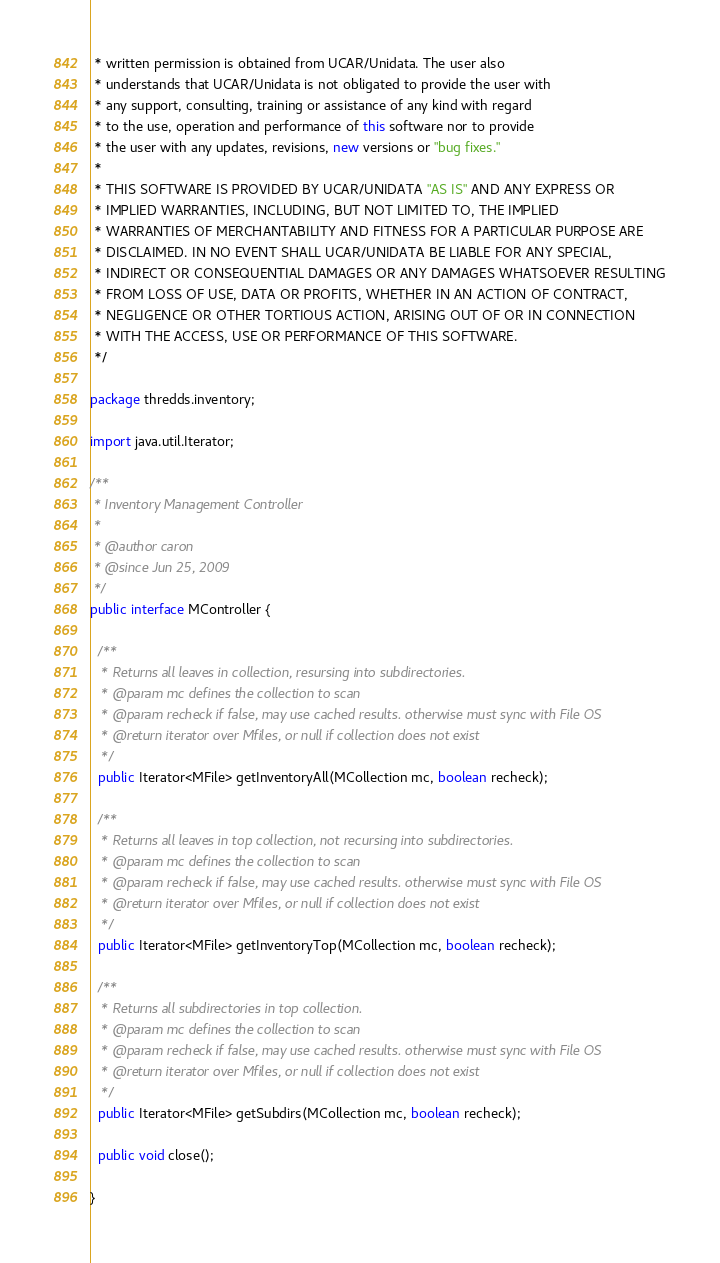Convert code to text. <code><loc_0><loc_0><loc_500><loc_500><_Java_> * written permission is obtained from UCAR/Unidata. The user also
 * understands that UCAR/Unidata is not obligated to provide the user with
 * any support, consulting, training or assistance of any kind with regard
 * to the use, operation and performance of this software nor to provide
 * the user with any updates, revisions, new versions or "bug fixes."
 *
 * THIS SOFTWARE IS PROVIDED BY UCAR/UNIDATA "AS IS" AND ANY EXPRESS OR
 * IMPLIED WARRANTIES, INCLUDING, BUT NOT LIMITED TO, THE IMPLIED
 * WARRANTIES OF MERCHANTABILITY AND FITNESS FOR A PARTICULAR PURPOSE ARE
 * DISCLAIMED. IN NO EVENT SHALL UCAR/UNIDATA BE LIABLE FOR ANY SPECIAL,
 * INDIRECT OR CONSEQUENTIAL DAMAGES OR ANY DAMAGES WHATSOEVER RESULTING
 * FROM LOSS OF USE, DATA OR PROFITS, WHETHER IN AN ACTION OF CONTRACT,
 * NEGLIGENCE OR OTHER TORTIOUS ACTION, ARISING OUT OF OR IN CONNECTION
 * WITH THE ACCESS, USE OR PERFORMANCE OF THIS SOFTWARE.
 */

package thredds.inventory;

import java.util.Iterator;

/**
 * Inventory Management Controller
 *
 * @author caron
 * @since Jun 25, 2009
 */
public interface MController {

  /**
   * Returns all leaves in collection, resursing into subdirectories.
   * @param mc defines the collection to scan
   * @param recheck if false, may use cached results. otherwise must sync with File OS
   * @return iterator over Mfiles, or null if collection does not exist
   */
  public Iterator<MFile> getInventoryAll(MCollection mc, boolean recheck);

  /**
   * Returns all leaves in top collection, not recursing into subdirectories.
   * @param mc defines the collection to scan
   * @param recheck if false, may use cached results. otherwise must sync with File OS
   * @return iterator over Mfiles, or null if collection does not exist
   */
  public Iterator<MFile> getInventoryTop(MCollection mc, boolean recheck);

  /**
   * Returns all subdirectories in top collection.
   * @param mc defines the collection to scan
   * @param recheck if false, may use cached results. otherwise must sync with File OS
   * @return iterator over Mfiles, or null if collection does not exist
   */
  public Iterator<MFile> getSubdirs(MCollection mc, boolean recheck);

  public void close();

}
</code> 